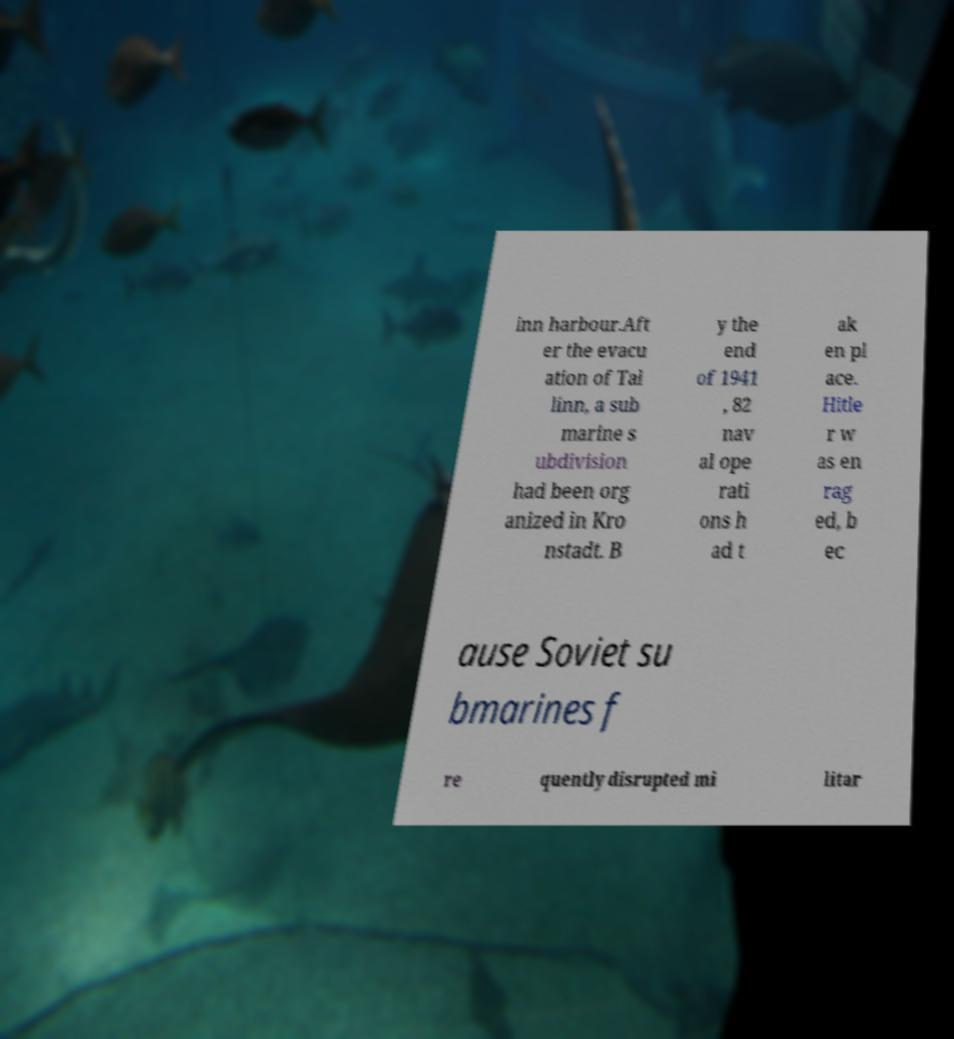Can you accurately transcribe the text from the provided image for me? inn harbour.Aft er the evacu ation of Tal linn, a sub marine s ubdivision had been org anized in Kro nstadt. B y the end of 1941 , 82 nav al ope rati ons h ad t ak en pl ace. Hitle r w as en rag ed, b ec ause Soviet su bmarines f re quently disrupted mi litar 